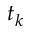Convert formula to latex. <formula><loc_0><loc_0><loc_500><loc_500>t _ { k }</formula> 